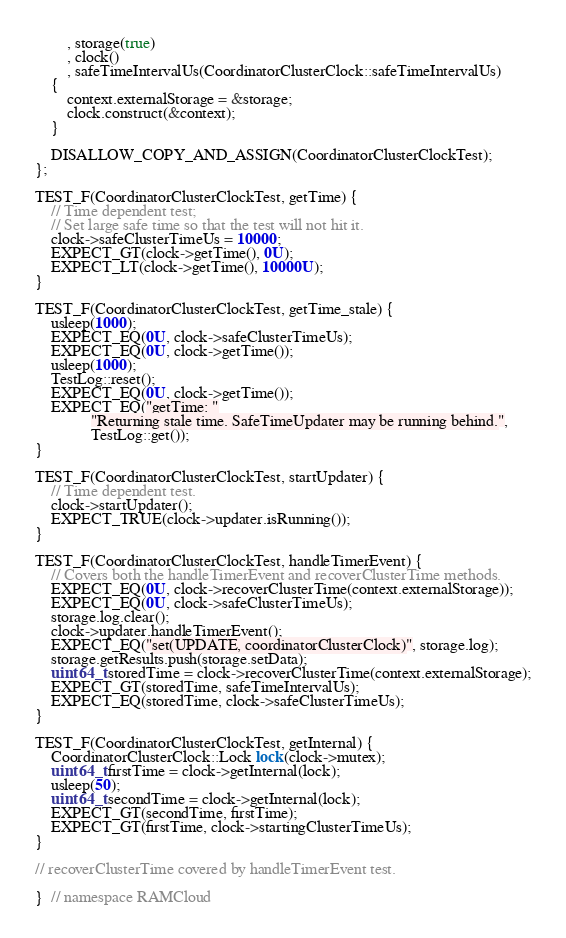<code> <loc_0><loc_0><loc_500><loc_500><_C++_>        , storage(true)
        , clock()
        , safeTimeIntervalUs(CoordinatorClusterClock::safeTimeIntervalUs)
    {
        context.externalStorage = &storage;
        clock.construct(&context);
    }

    DISALLOW_COPY_AND_ASSIGN(CoordinatorClusterClockTest);
};

TEST_F(CoordinatorClusterClockTest, getTime) {
    // Time dependent test;
    // Set large safe time so that the test will not hit it.
    clock->safeClusterTimeUs = 10000;
    EXPECT_GT(clock->getTime(), 0U);
    EXPECT_LT(clock->getTime(), 10000U);
}

TEST_F(CoordinatorClusterClockTest, getTime_stale) {
    usleep(1000);
    EXPECT_EQ(0U, clock->safeClusterTimeUs);
    EXPECT_EQ(0U, clock->getTime());
    usleep(1000);
    TestLog::reset();
    EXPECT_EQ(0U, clock->getTime());
    EXPECT_EQ("getTime: "
              "Returning stale time. SafeTimeUpdater may be running behind.",
              TestLog::get());
}

TEST_F(CoordinatorClusterClockTest, startUpdater) {
    // Time dependent test.
    clock->startUpdater();
    EXPECT_TRUE(clock->updater.isRunning());
}

TEST_F(CoordinatorClusterClockTest, handleTimerEvent) {
    // Covers both the handleTimerEvent and recoverClusterTime methods.
    EXPECT_EQ(0U, clock->recoverClusterTime(context.externalStorage));
    EXPECT_EQ(0U, clock->safeClusterTimeUs);
    storage.log.clear();
    clock->updater.handleTimerEvent();
    EXPECT_EQ("set(UPDATE, coordinatorClusterClock)", storage.log);
    storage.getResults.push(storage.setData);
    uint64_t storedTime = clock->recoverClusterTime(context.externalStorage);
    EXPECT_GT(storedTime, safeTimeIntervalUs);
    EXPECT_EQ(storedTime, clock->safeClusterTimeUs);
}

TEST_F(CoordinatorClusterClockTest, getInternal) {
    CoordinatorClusterClock::Lock lock(clock->mutex);
    uint64_t firstTime = clock->getInternal(lock);
    usleep(50);
    uint64_t secondTime = clock->getInternal(lock);
    EXPECT_GT(secondTime, firstTime);
    EXPECT_GT(firstTime, clock->startingClusterTimeUs);
}

// recoverClusterTime covered by handleTimerEvent test.

}  // namespace RAMCloud
</code> 